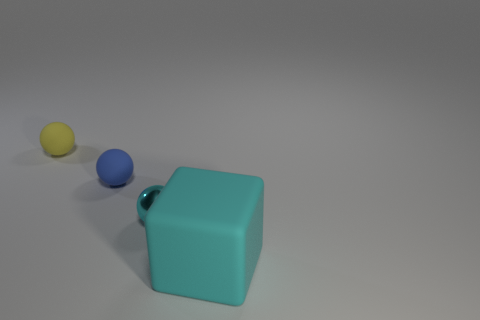Add 3 big green rubber spheres. How many objects exist? 7 Subtract all spheres. How many objects are left? 1 Subtract 0 purple balls. How many objects are left? 4 Subtract all tiny yellow metallic objects. Subtract all rubber objects. How many objects are left? 1 Add 2 big cyan matte cubes. How many big cyan matte cubes are left? 3 Add 3 tiny cyan metallic spheres. How many tiny cyan metallic spheres exist? 4 